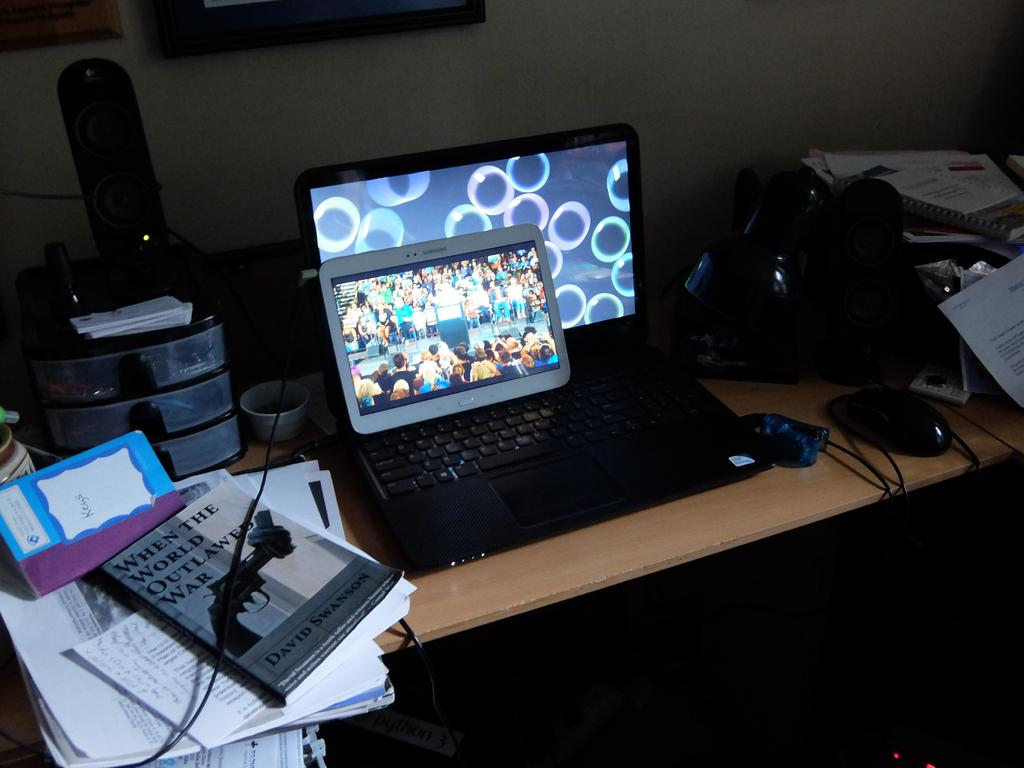<image>
Summarize the visual content of the image. Next to a tablet and laptop lies a book called When the world outlawed war. 